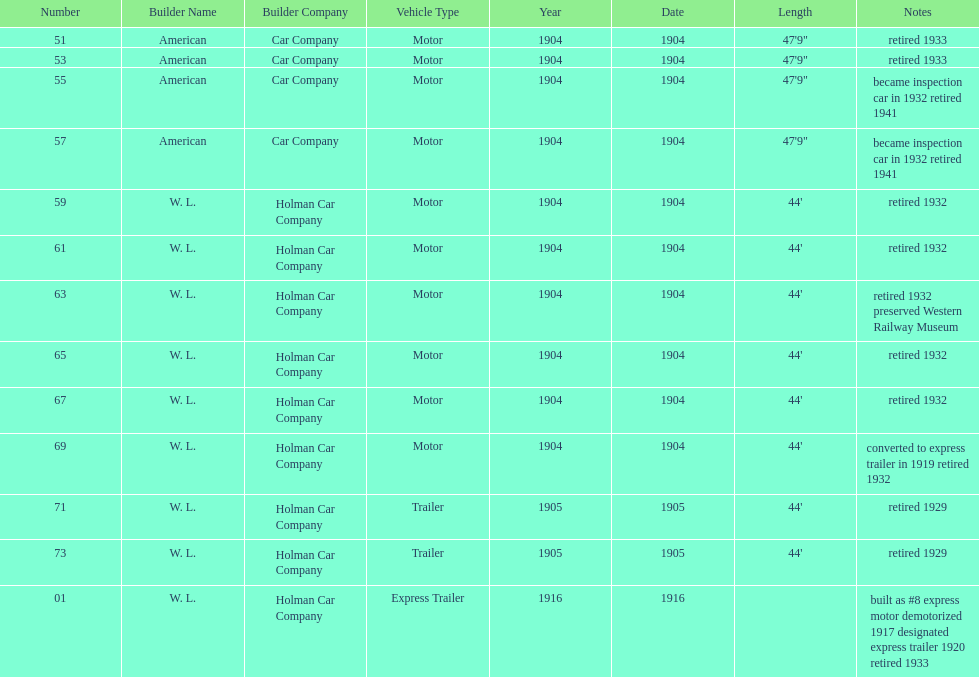What was the number of cars built by american car company? 4. 